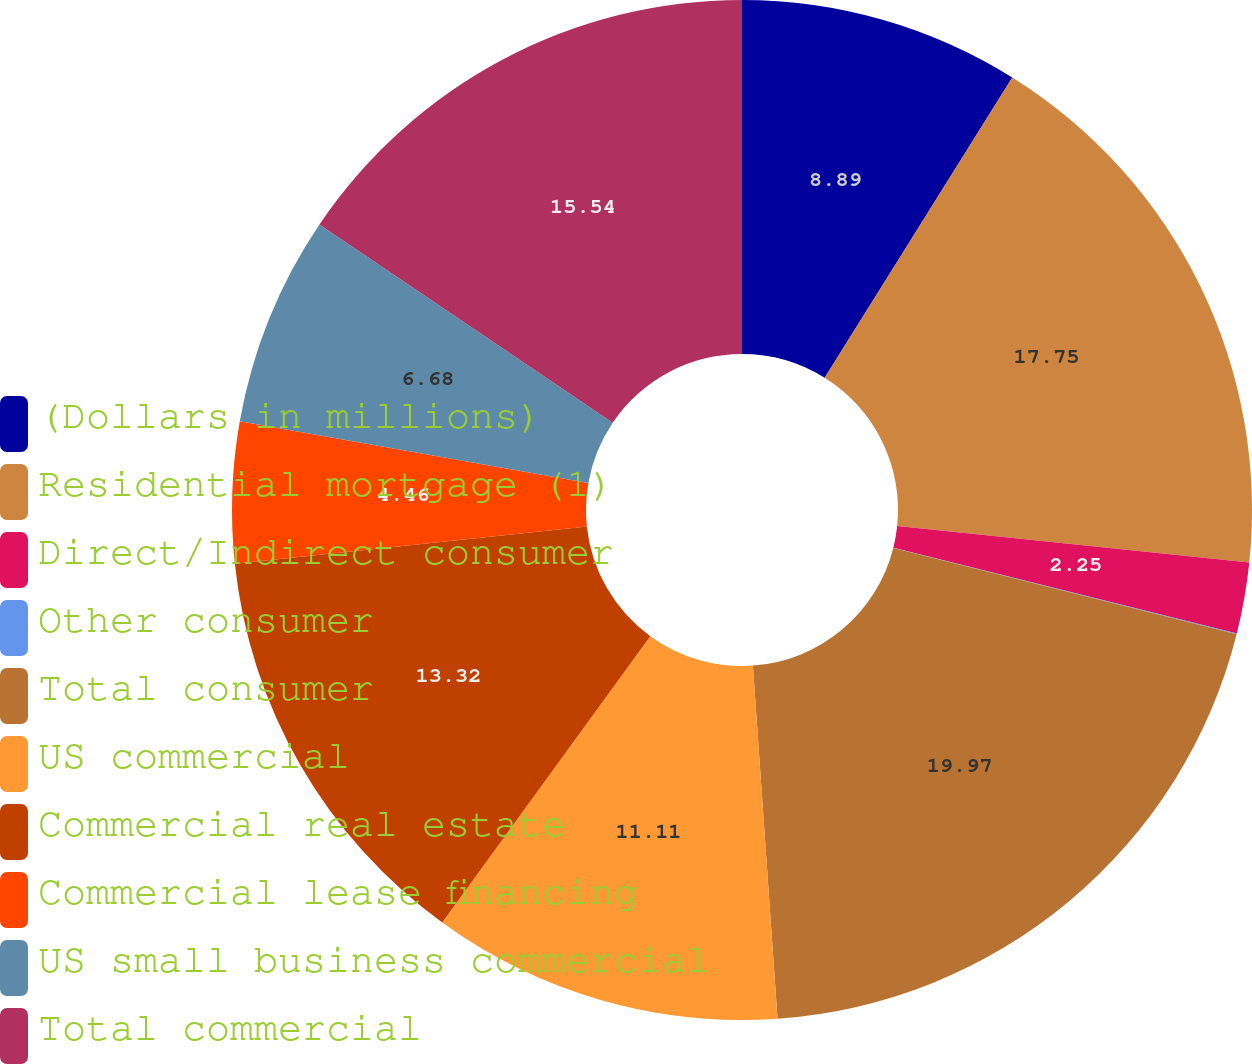<chart> <loc_0><loc_0><loc_500><loc_500><pie_chart><fcel>(Dollars in millions)<fcel>Residential mortgage (1)<fcel>Direct/Indirect consumer<fcel>Other consumer<fcel>Total consumer<fcel>US commercial<fcel>Commercial real estate<fcel>Commercial lease financing<fcel>US small business commercial<fcel>Total commercial<nl><fcel>8.89%<fcel>17.75%<fcel>2.25%<fcel>0.03%<fcel>19.97%<fcel>11.11%<fcel>13.32%<fcel>4.46%<fcel>6.68%<fcel>15.54%<nl></chart> 